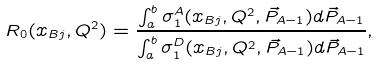<formula> <loc_0><loc_0><loc_500><loc_500>R _ { 0 } ( x _ { B j } , Q ^ { 2 } ) = { \frac { \int _ { a } ^ { b } \sigma _ { 1 } ^ { A } ( x _ { B j } , Q ^ { 2 } , \vec { P } _ { A - 1 } ) d \vec { P } _ { A - 1 } } { \int _ { a } ^ { b } \sigma _ { 1 } ^ { D } ( x _ { B j } , Q ^ { 2 } , \vec { P } _ { A - 1 } ) d \vec { P } _ { A - 1 } } } ,</formula> 